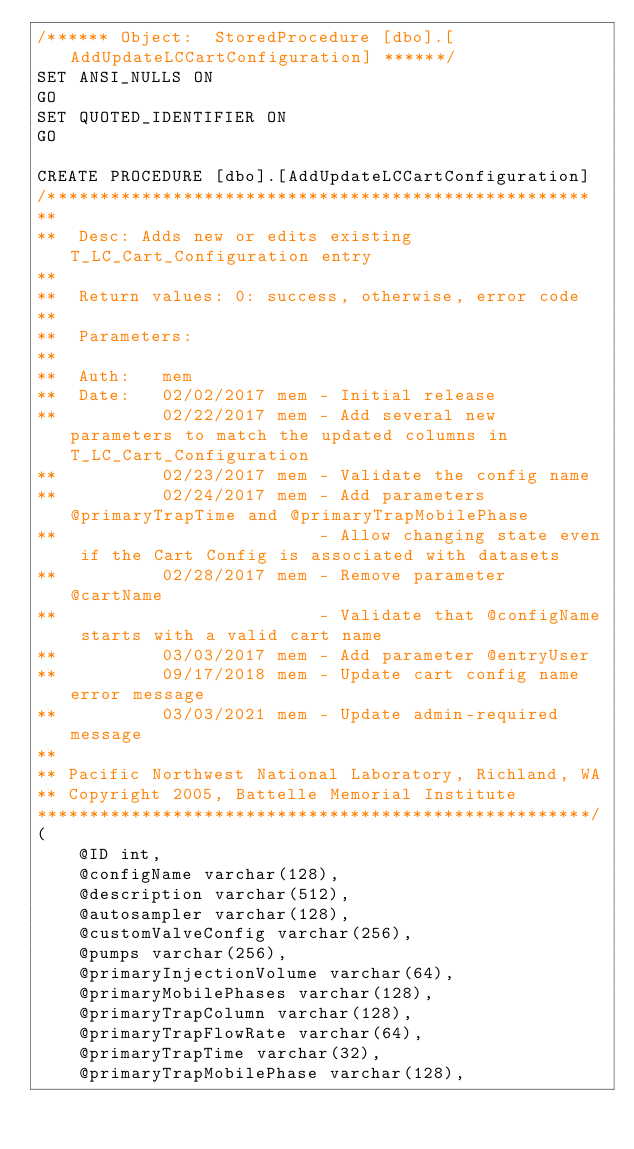<code> <loc_0><loc_0><loc_500><loc_500><_SQL_>/****** Object:  StoredProcedure [dbo].[AddUpdateLCCartConfiguration] ******/
SET ANSI_NULLS ON
GO
SET QUOTED_IDENTIFIER ON
GO

CREATE PROCEDURE [dbo].[AddUpdateLCCartConfiguration]
/****************************************************
**
**  Desc: Adds new or edits existing T_LC_Cart_Configuration entry
**
**  Return values: 0: success, otherwise, error code
**
**  Parameters:
**
**  Auth:   mem
**  Date:   02/02/2017 mem - Initial release
**          02/22/2017 mem - Add several new parameters to match the updated columns in T_LC_Cart_Configuration
**          02/23/2017 mem - Validate the config name
**          02/24/2017 mem - Add parameters @primaryTrapTime and @primaryTrapMobilePhase
**                         - Allow changing state even if the Cart Config is associated with datasets
**          02/28/2017 mem - Remove parameter @cartName
**                         - Validate that @configName starts with a valid cart name
**          03/03/2017 mem - Add parameter @entryUser
**          09/17/2018 mem - Update cart config name error message
**          03/03/2021 mem - Update admin-required message
**    
** Pacific Northwest National Laboratory, Richland, WA
** Copyright 2005, Battelle Memorial Institute
*****************************************************/
(
    @ID int,
    @configName varchar(128),
    @description varchar(512),
    @autosampler varchar(128),
    @customValveConfig varchar(256),
    @pumps varchar(256),
    @primaryInjectionVolume varchar(64),
    @primaryMobilePhases varchar(128),
    @primaryTrapColumn varchar(128),
    @primaryTrapFlowRate varchar(64),
    @primaryTrapTime varchar(32),
    @primaryTrapMobilePhase varchar(128),</code> 